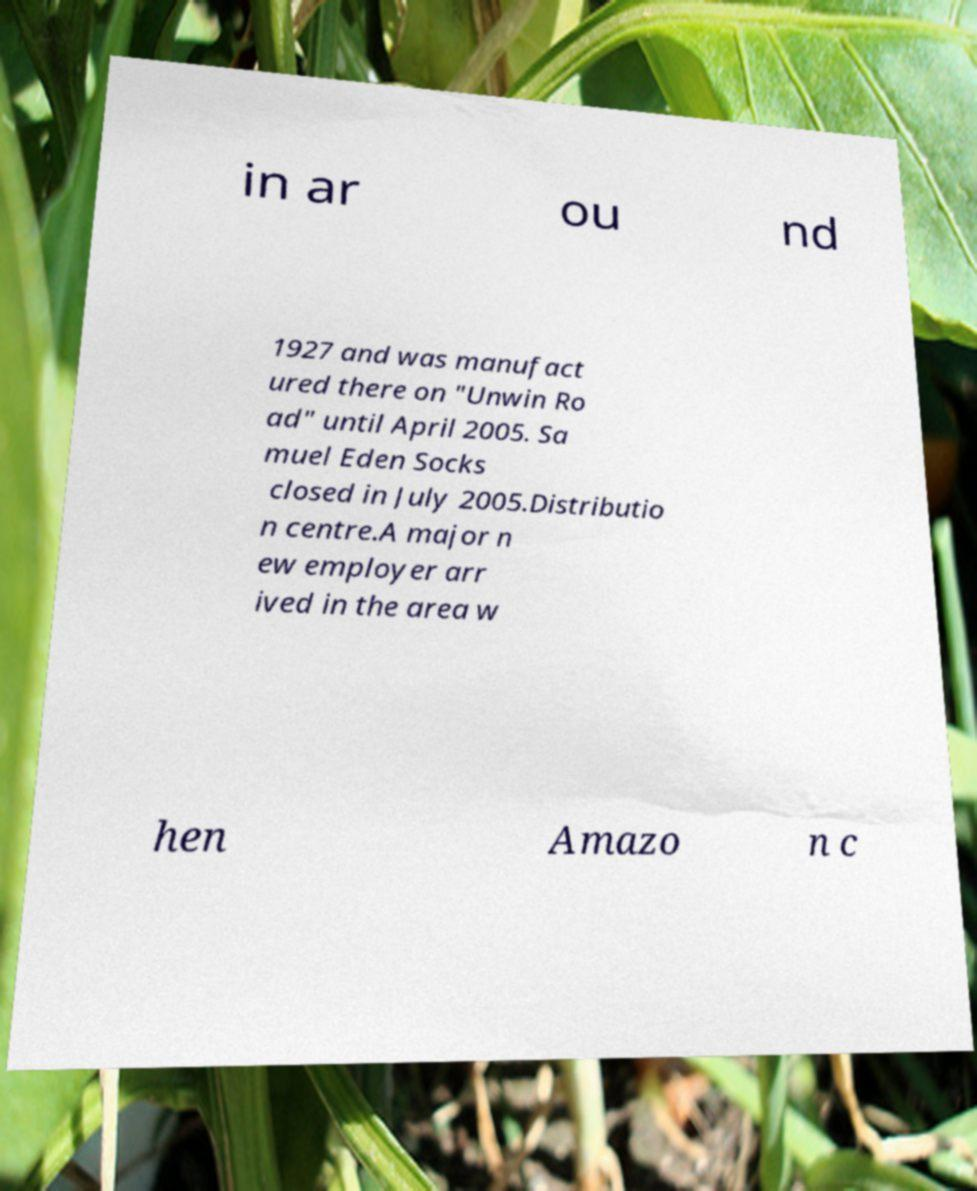What messages or text are displayed in this image? I need them in a readable, typed format. in ar ou nd 1927 and was manufact ured there on "Unwin Ro ad" until April 2005. Sa muel Eden Socks closed in July 2005.Distributio n centre.A major n ew employer arr ived in the area w hen Amazo n c 